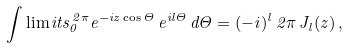Convert formula to latex. <formula><loc_0><loc_0><loc_500><loc_500>\int \lim i t s _ { 0 } ^ { \, 2 \pi } e ^ { - i z \cos { \Theta } } \, e ^ { i l \Theta } \, d \Theta = ( - i ) ^ { l } \, 2 \pi \, J _ { l } ( z ) \, ,</formula> 